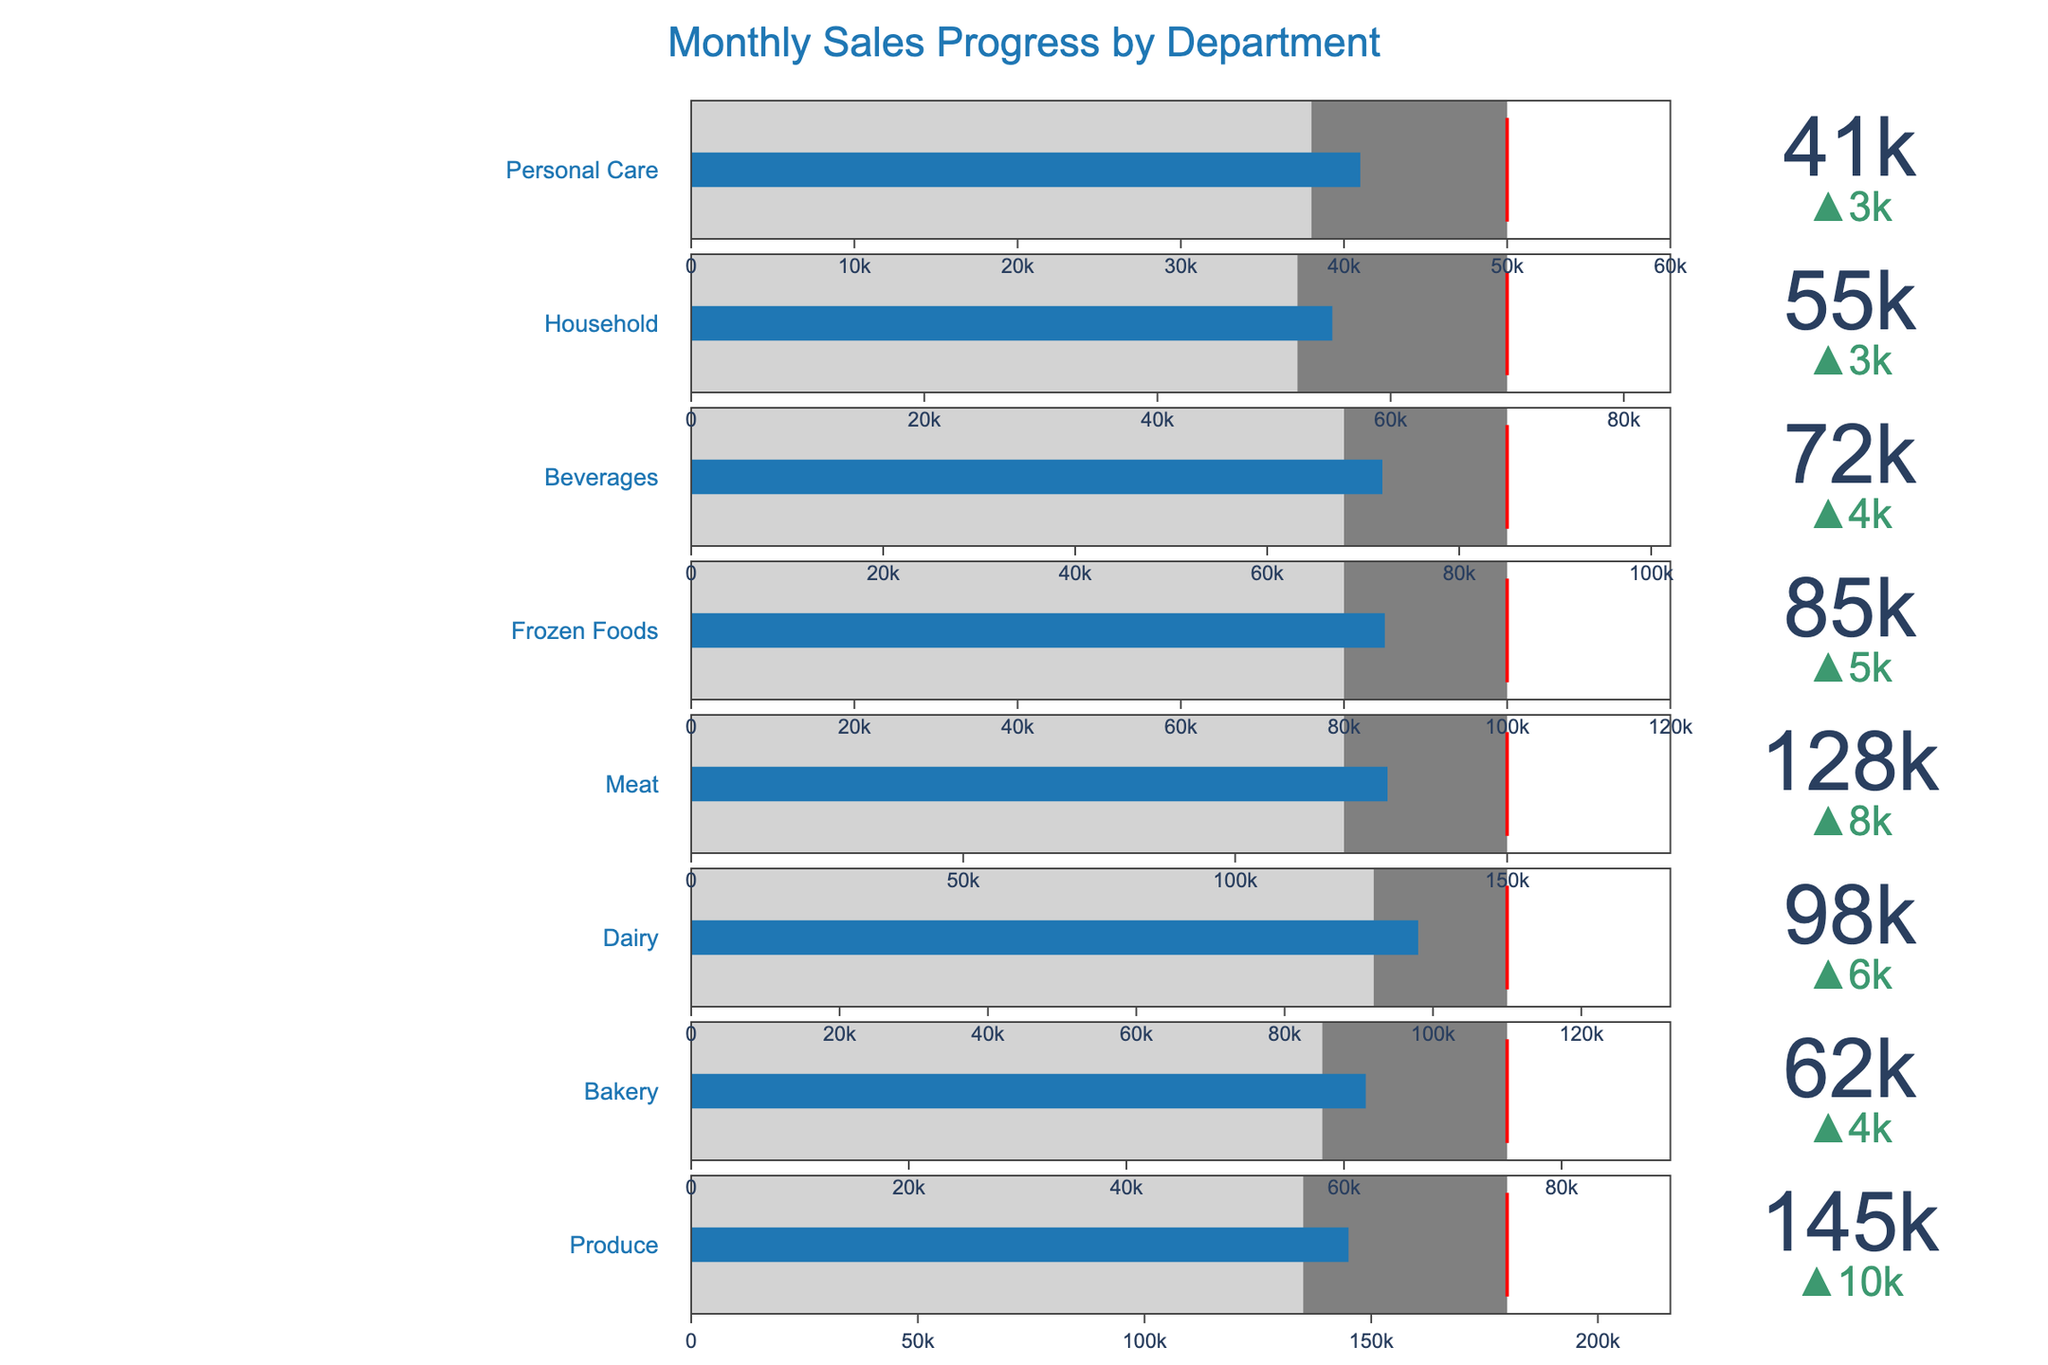What's the title of the figure? The title of the figure is located at the top-center and reads "Monthly Sales Progress by Department".
Answer: Monthly Sales Progress by Department How many departments are displayed in the figure? The figure shows the monthly sales progress for different departments. There are eight distinct departments listed: Produce, Bakery, Dairy, Meat, Frozen Foods, Beverages, Household, and Personal Care.
Answer: Eight What is the actual sales figure for the Beverages department? Look for the Beverages department and check the value indicated on the bullet chart element for Beverages. The actual sales figure is recorded as 72,000.
Answer: 72,000 Which department has the highest target for monthly sales? To find the department with the highest target, review the target markers on the bullet charts for each department and compare them. The Produce department has the highest target with 180,000.
Answer: Produce How much did the Dairy department miss its target by? For the Dairy department, compare its actual sales (98,000) to its target (110,000). The difference between the actual sales and the target is calculated as 110,000 - 98,000 = 12,000.
Answer: 12,000 Which department had the greatest increase in sales compared to the previous year? To determine the greatest increase, compare the delta values (difference from previous year) for each department. The Produce department has the highest increase indicated by the delta in the bullet chart, which is 10,000 (145,000-135,000).
Answer: Produce How many departments met or exceeded their previous year sales? Examine each department's actual sales and compare it to the previous year's value to count the departments that met or exceeded last year's sales. Produce, Bakery, Dairy, Meat, Frozen Foods, Beverages, and Household all met or exceeded previous year’s sales. Personal Care did not. Thus, the total is 7.
Answer: Seven Which department is closest to reaching its sales target in percentage terms? Calculate the percentage of the target met for each department by dividing actual sales by the target, then identify the highest percentage. Dairy department reached about 89% (98,000/110,000), which is closest to its target compared to other departments.
Answer: Dairy What color represents the range between the previous year's sales and the target sales on the bullet charts? The color used to represent the range between the previous year's sales and the target sales is gray, which is indicated in the steps of the gauge element in each bullet chart.
Answer: Gray 